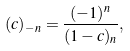Convert formula to latex. <formula><loc_0><loc_0><loc_500><loc_500>( c ) _ { - n } = \frac { ( - 1 ) ^ { n } } { ( 1 - c ) _ { n } } ,</formula> 